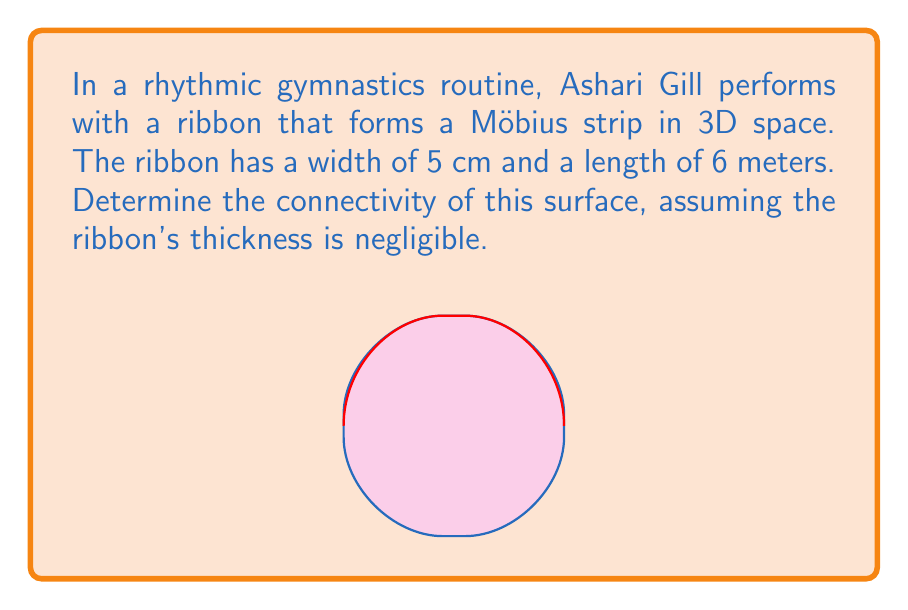Can you solve this math problem? To determine the connectivity of the Möbius strip, we need to follow these steps:

1) First, recall that connectivity in topology refers to the number of cuts needed to separate a surface into two disconnected pieces.

2) A Möbius strip is a non-orientable surface with only one side and one edge. It's formed by taking a rectangular strip and giving it a half-twist before joining the ends.

3) The key property of a Möbius strip is that it remains in one piece and becomes a simple loop if cut along its center line.

4) If we make a single cut along the center of the Möbius strip (parallel to its edge), we don't separate it into two pieces. Instead, we get a single, longer strip with two full twists.

5) To actually separate the Möbius strip into two disconnected pieces, we need to make a second cut parallel to the first one.

6) Therefore, the Möbius strip requires two cuts to be separated into disconnected pieces.

7) In topological terms, this means the Möbius strip has a connectivity of 2.

8) The width (5 cm) and length (6 m) of the ribbon don't affect its topological properties, as long as the strip can complete a full twist.
Answer: 2 